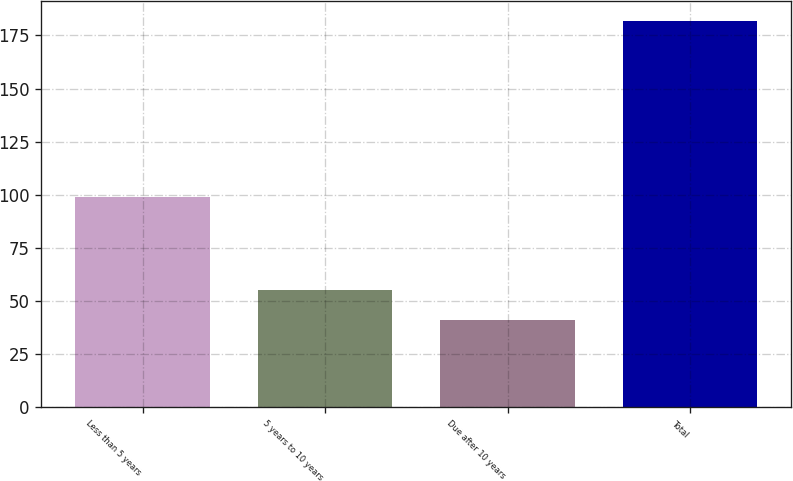<chart> <loc_0><loc_0><loc_500><loc_500><bar_chart><fcel>Less than 5 years<fcel>5 years to 10 years<fcel>Due after 10 years<fcel>Total<nl><fcel>99<fcel>55.1<fcel>41<fcel>182<nl></chart> 